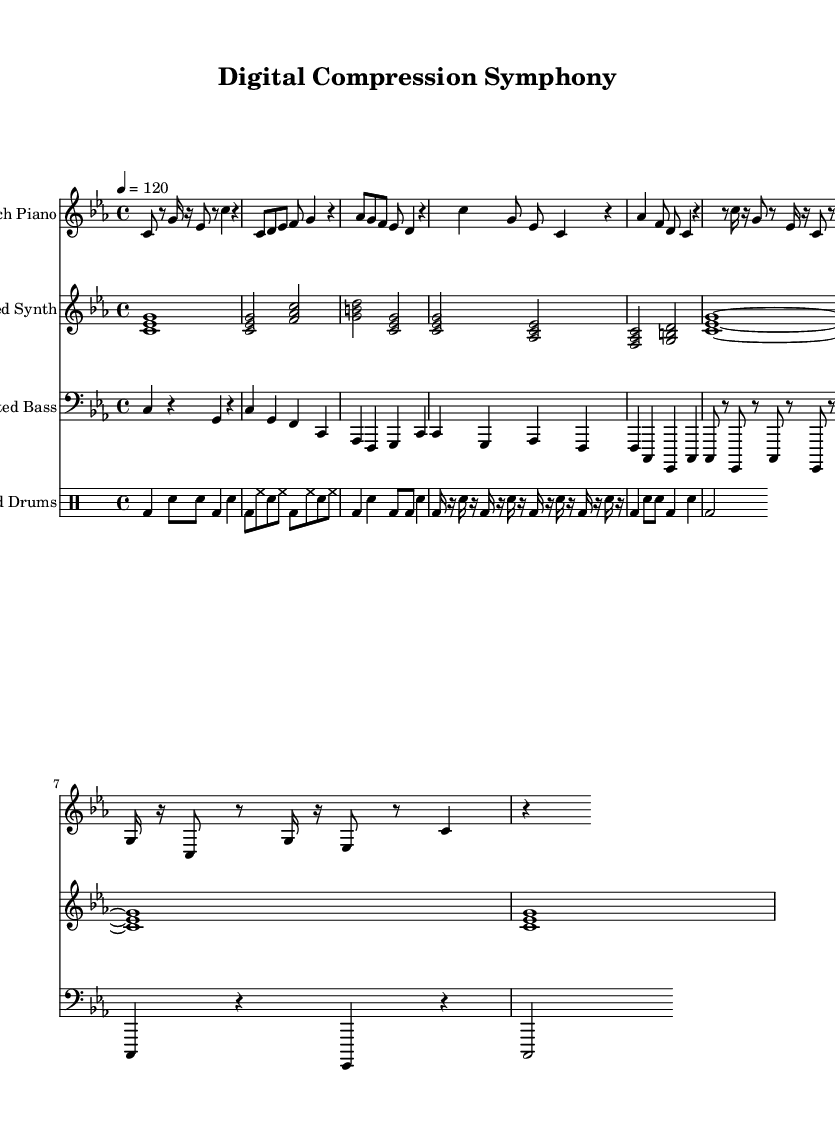What is the key signature of this music? The key signature is C minor, which has three flats indicated by the notation at the beginning of the score.
Answer: C minor What is the time signature of this composition? The time signature is 4/4, meaning there are four beats per measure and the quarter note gets one beat. This can be identified in the score where it is notated.
Answer: 4/4 What is the tempo marking given in the sheet music? The tempo marking is indicated as quarter note equals 120, which tells us that each quarter note should be played at a speed of 120 beats per minute.
Answer: 120 How many measures are in the 'Chorus' section? The 'Chorus' section consists of four measures, which can be counted in the notation of the musical line designated for the chorus.
Answer: 4 What type of instrument is used for the 'Bit-crushed Synth'? The instrument for the 'Bit-crushed Synth' is labeled as a synth. This can be derived from the staff header in the score indicating the instrument type.
Answer: Synth What rhythmic pattern is primarily featured in the 'Compressed Drums' section? The rhythmic pattern in the 'Compressed Drums' uses a combination of bass drum and snare hits, structured specifically in various measure formats as seen in that part of the score.
Answer: Bass and snare What musical technique is primarily used in the 'glitchPiano' part? The 'glitchPiano' part employs interruptions and irregular rhythms to create a sense of digital distortion typical of glitch music. These characteristics can be found in the variations of note lengths and rests.
Answer: Glitch 